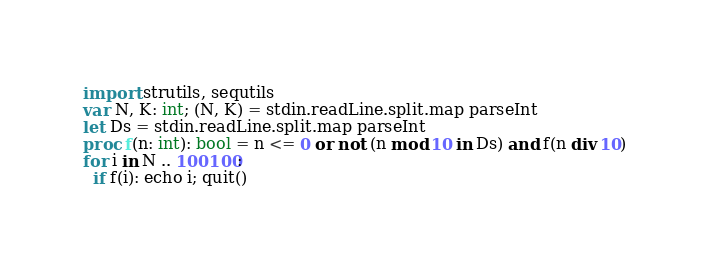<code> <loc_0><loc_0><loc_500><loc_500><_Nim_>import strutils, sequtils
var N, K: int; (N, K) = stdin.readLine.split.map parseInt
let Ds = stdin.readLine.split.map parseInt
proc f(n: int): bool = n <= 0 or not (n mod 10 in Ds) and f(n div 10)
for i in N .. 100100:
  if f(i): echo i; quit()</code> 